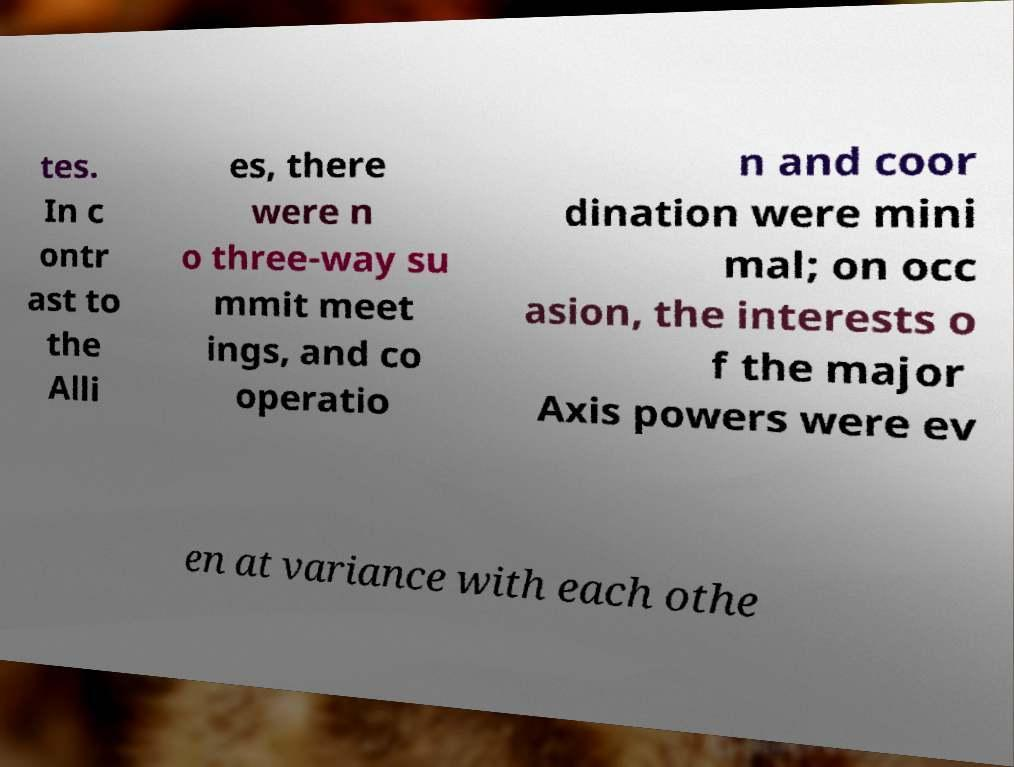Could you extract and type out the text from this image? tes. In c ontr ast to the Alli es, there were n o three-way su mmit meet ings, and co operatio n and coor dination were mini mal; on occ asion, the interests o f the major Axis powers were ev en at variance with each othe 